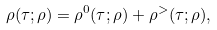<formula> <loc_0><loc_0><loc_500><loc_500>\rho ( \tau ; \rho ) = \rho ^ { 0 } ( \tau ; \rho ) + \rho ^ { > } ( \tau ; \rho ) ,</formula> 